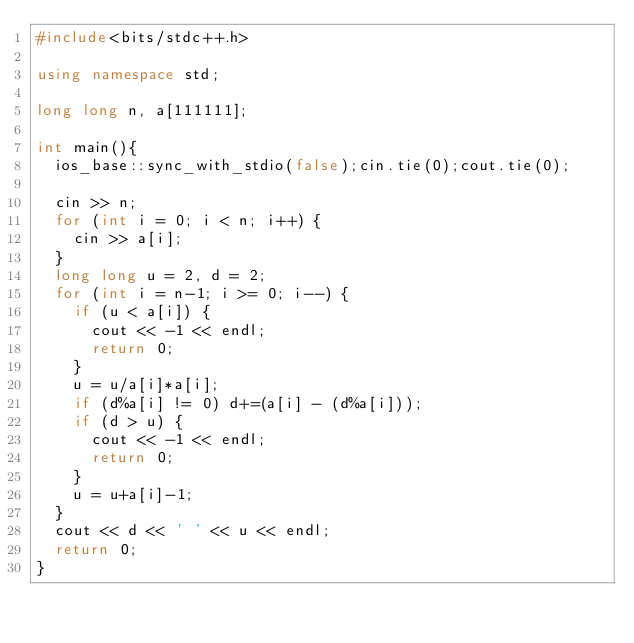<code> <loc_0><loc_0><loc_500><loc_500><_C++_>#include<bits/stdc++.h>

using namespace std;

long long n, a[111111];

int main(){
	ios_base::sync_with_stdio(false);cin.tie(0);cout.tie(0);

	cin >> n;
	for (int i = 0; i < n; i++) {
		cin >> a[i];
	}
	long long u = 2, d = 2;
	for (int i = n-1; i >= 0; i--) {
		if (u < a[i]) {
			cout << -1 << endl;
			return 0;
		}
		u = u/a[i]*a[i];
		if (d%a[i] != 0) d+=(a[i] - (d%a[i]));
		if (d > u) {
			cout << -1 << endl;
			return 0;
		}
		u = u+a[i]-1;
	}
	cout << d << ' ' << u << endl;
	return 0;
}
</code> 